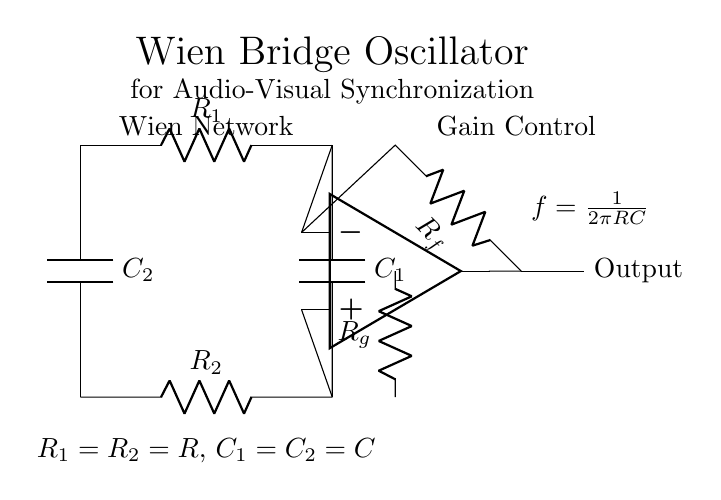What type of amplifier is used in this circuit? The circuit includes an operational amplifier, identifiable by the symbol with a triangle pointing towards the output and two inputs (inverting and non-inverting). This confirms it is an op-amp.
Answer: operational amplifier What is the function of the resistors R1 and R2 in the Wien bridge oscillator? R1 and R2 form the Wien network, which establishes a frequency-dependent relationship with capacitors to determine the oscillator's output frequency.
Answer: determine frequency What is the output frequency formula shown in the circuit? The formula displayed next to the circuit is f = 1/(2πRC), indicating how frequency depends on the components' resistance and capacitance values in the oscillator.
Answer: f = 1/(2πRC) What roles do capacitors C1 and C2 play in the circuit? Capacitors C1 and C2 work with resistors R1 and R2 to set the oscillation frequency and help stabilize the gain of the op-amp, balancing the circuit dynamics.
Answer: set oscillation frequency What is the gain control mechanism referenced in the circuit? The gain control is implemented using resistors Rf and Rg, where Rf influences the feedback loop and Rg helps to set a controlled gain for the operational amplifier output.
Answer: Rf and Rg What is the significance of feedback in this oscillator circuit? Feedback in the Wien bridge oscillator allows for stable oscillation by ensuring that a portion of the output voltage is fed back to the input, thus controlling the gain and oscillation conditions.
Answer: stable oscillation What are the values of R1 and R2 in the Wien network? Both R1 and R2 are indicated as having the same resistance value, R, which is a condition necessary for proper functioning of the Wien bridge oscillator.
Answer: R1 = R2 = R 